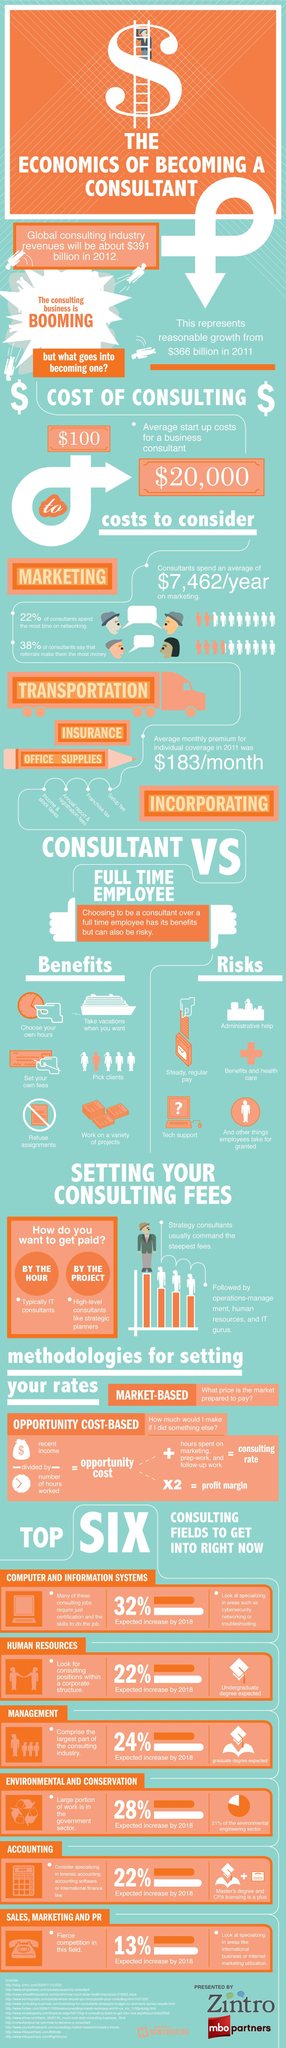Mention a couple of crucial points in this snapshot. In economics, the relationship between opportunity cost and profit margin is that the opportunity cost is equal to the profit margin. Opportunity cost refers to the value of the next best alternative forgone, while profit margin refers to the percentage of revenue remaining after deducting the cost of production. Together, these two concepts are important in evaluating business decisions and the efficiency of an organization's operations. The annual cost of marketing expenditure incurred by consultants is $7,462 per year. The sources listed at the bottom consist of 12 items. The revenue generated by the global consulting industry from 2011 to 2012 increased by approximately $25 billion. 